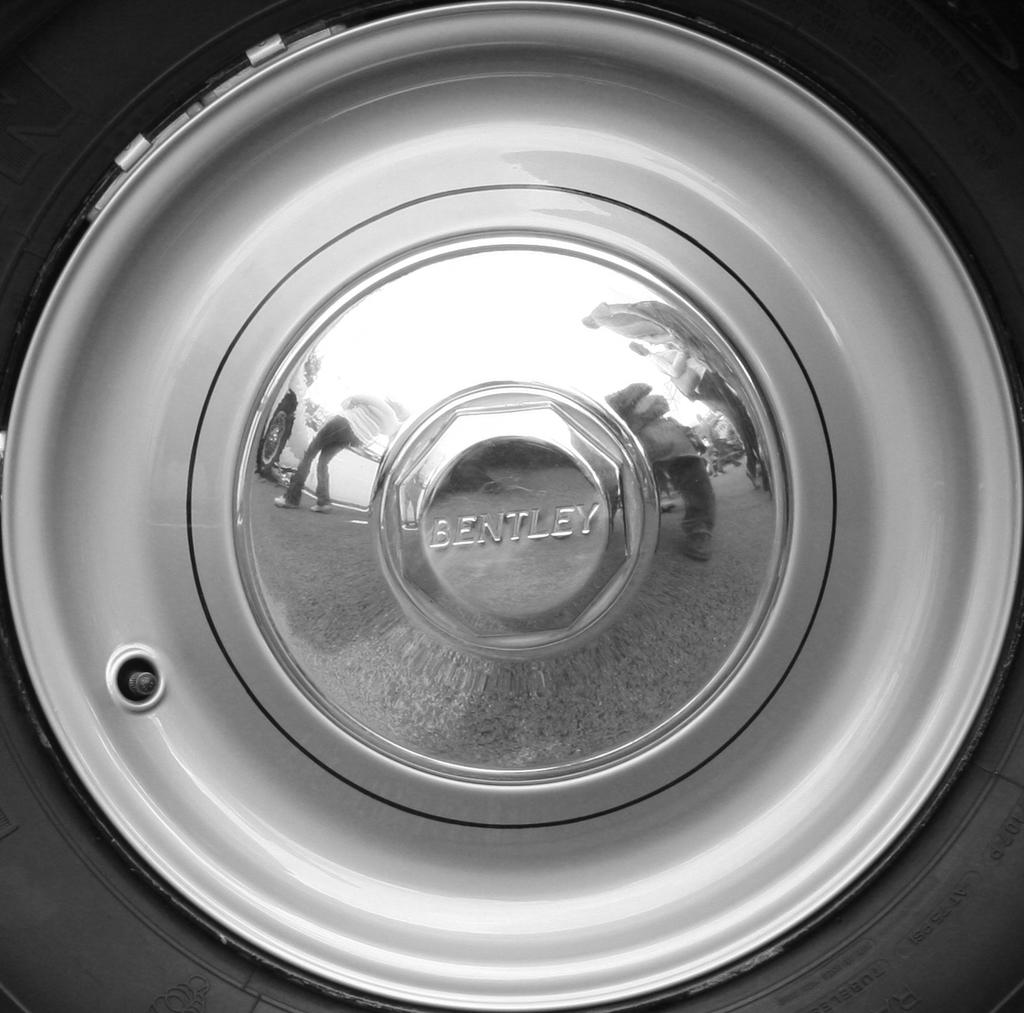What is the main subject of the image? The main subject of the image is a wheel of a vehicle. Can you describe any specific details about the wheel? Yes, the reflection of persons is visible on the alloy of the wheel. Is there any text present in the image? Yes, there is some text visible in the image. What type of scarf is being used to care for the wheel in the image? There is no scarf present in the image, nor is there any indication of caring for the wheel. 